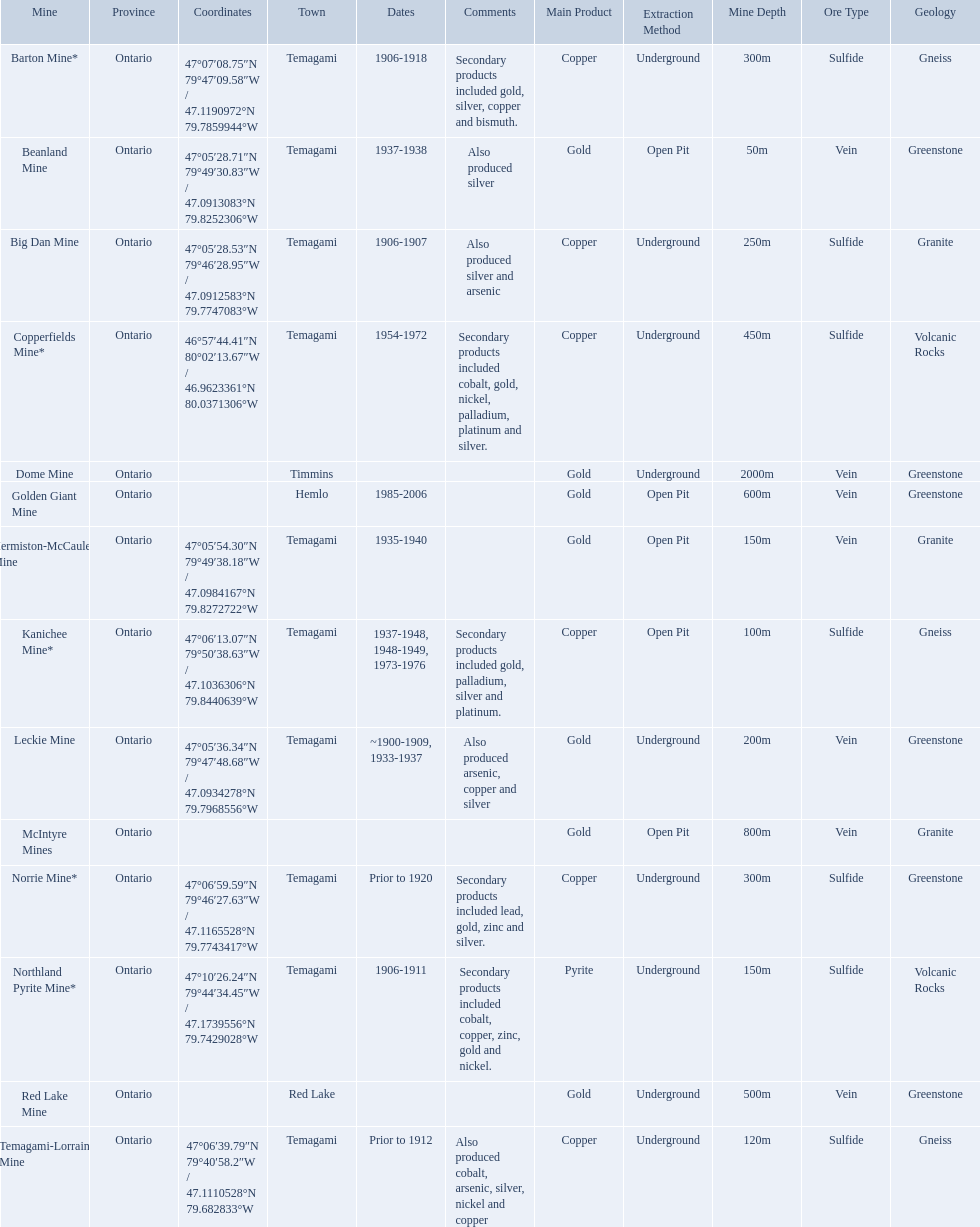What dates was the golden giant mine open? 1985-2006. What dates was the beanland mine open? 1937-1938. Of those mines, which was open longer? Golden Giant Mine. 